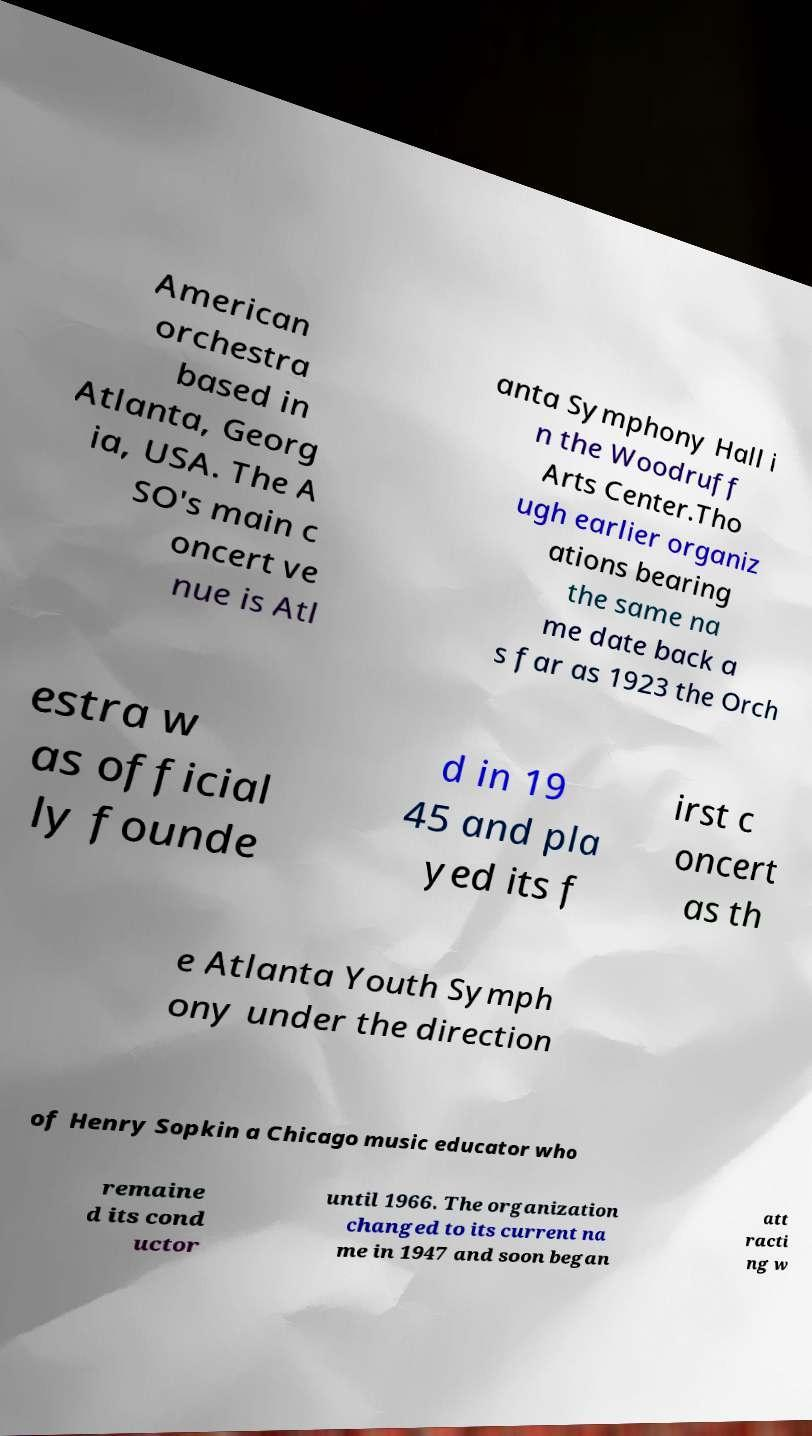Can you read and provide the text displayed in the image?This photo seems to have some interesting text. Can you extract and type it out for me? American orchestra based in Atlanta, Georg ia, USA. The A SO's main c oncert ve nue is Atl anta Symphony Hall i n the Woodruff Arts Center.Tho ugh earlier organiz ations bearing the same na me date back a s far as 1923 the Orch estra w as official ly founde d in 19 45 and pla yed its f irst c oncert as th e Atlanta Youth Symph ony under the direction of Henry Sopkin a Chicago music educator who remaine d its cond uctor until 1966. The organization changed to its current na me in 1947 and soon began att racti ng w 